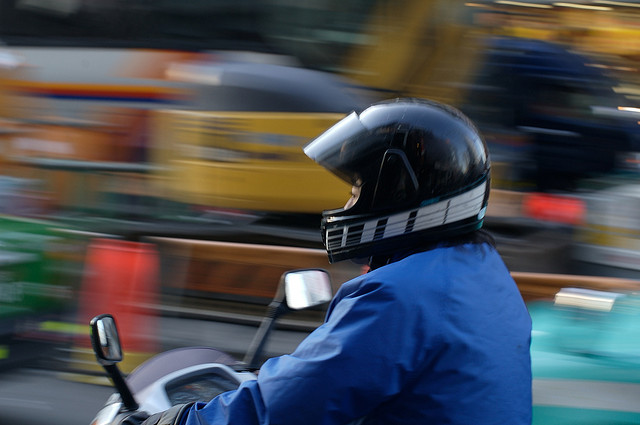<image>What object are people holding to protect themselves from rain? I am not sure. They can be holding an umbrella or nothing. What object are people holding to protect themselves from rain? People are holding umbrellas to protect themselves from rain. 